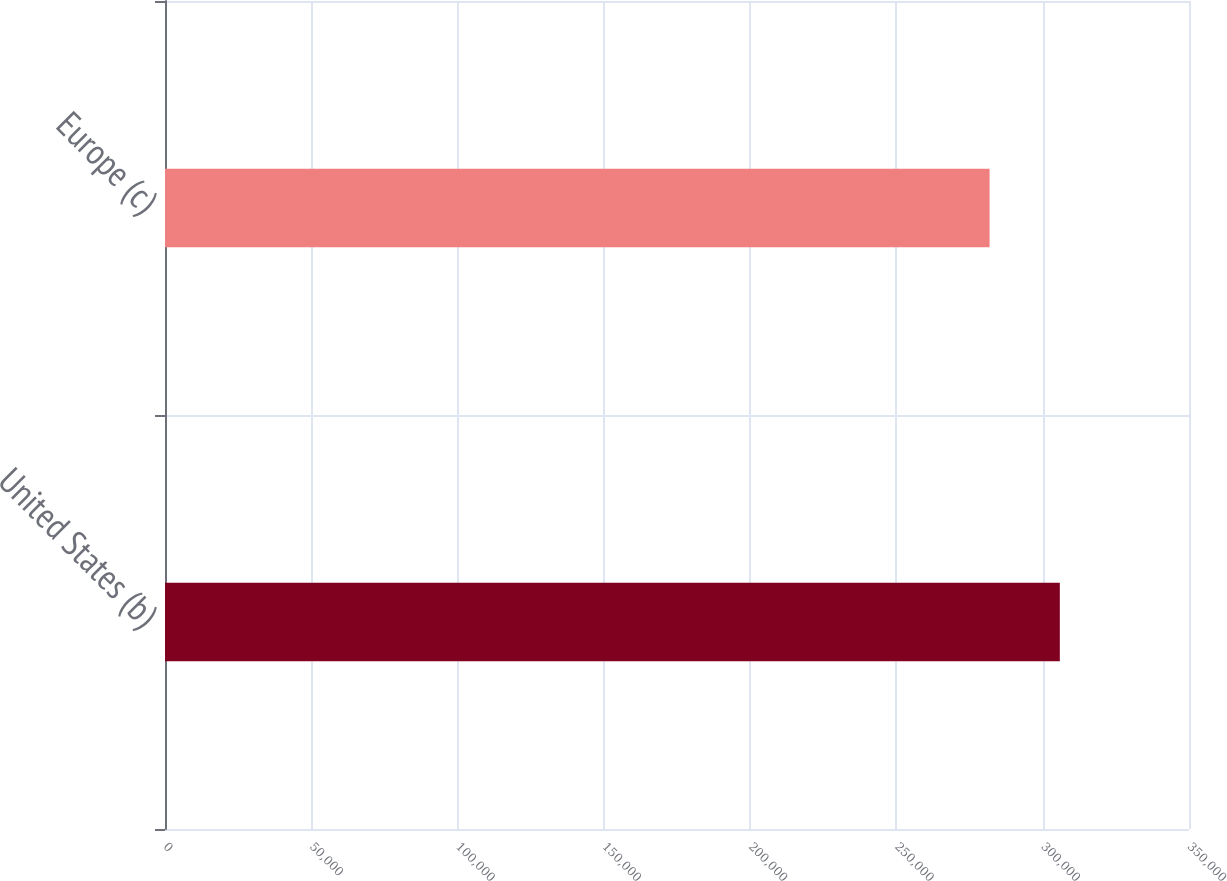<chart> <loc_0><loc_0><loc_500><loc_500><bar_chart><fcel>United States (b)<fcel>Europe (c)<nl><fcel>305852<fcel>281844<nl></chart> 